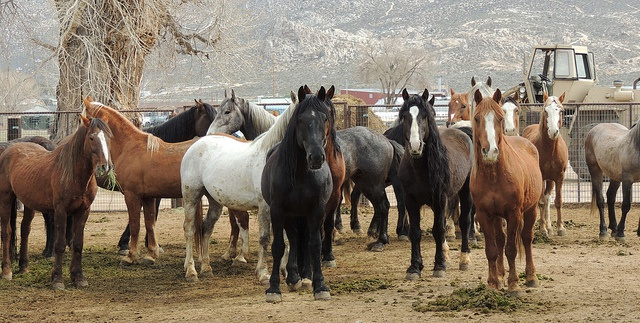Describe the objects in this image and their specific colors. I can see horse in gray, black, and tan tones, horse in gray, black, and maroon tones, horse in gray, black, tan, and maroon tones, horse in gray, lightgray, and darkgray tones, and horse in gray, maroon, black, and brown tones in this image. 